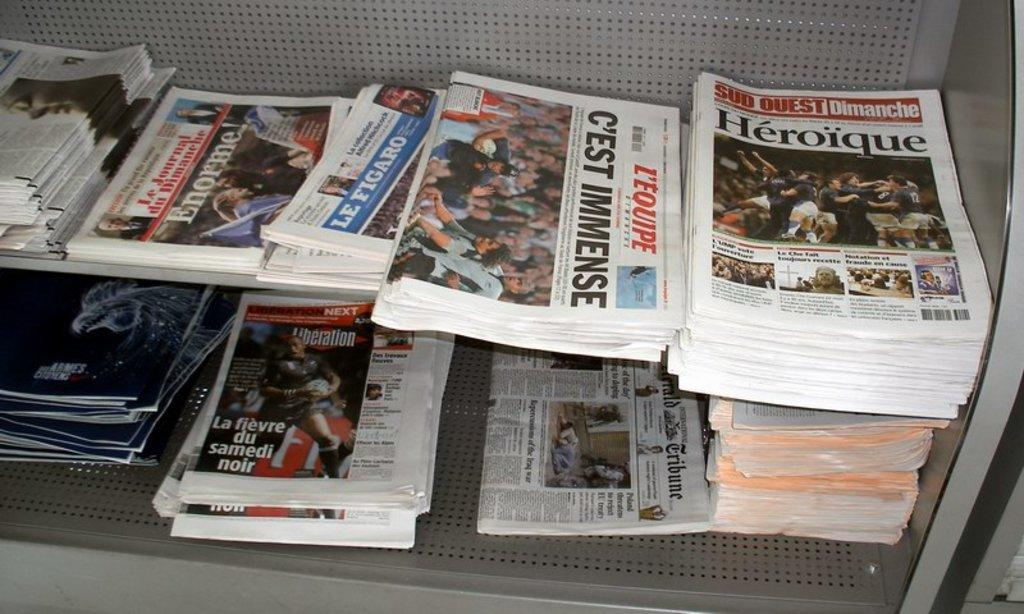<image>
Share a concise interpretation of the image provided. newspaper stacks with the title of one saying 'c'est immense' 